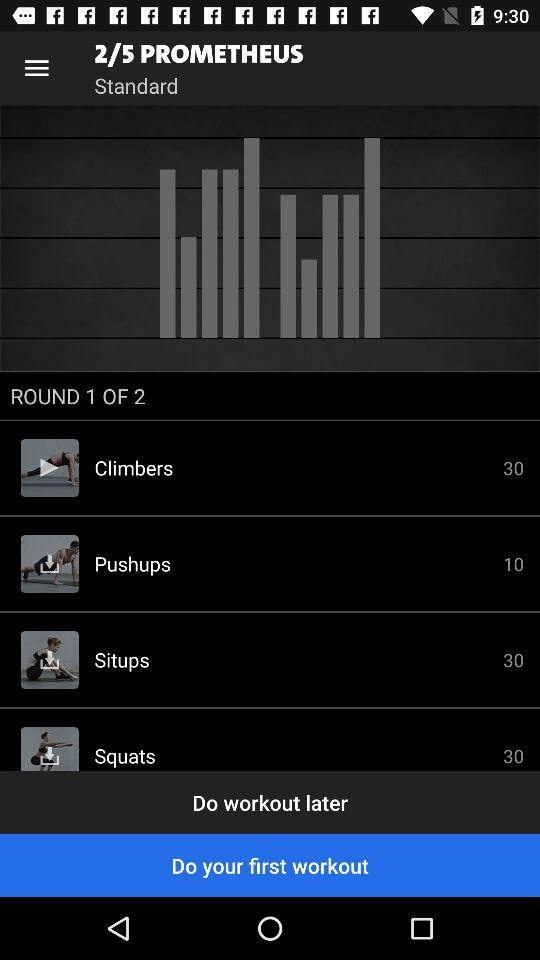How many rounds are there? There are 2 rounds. 